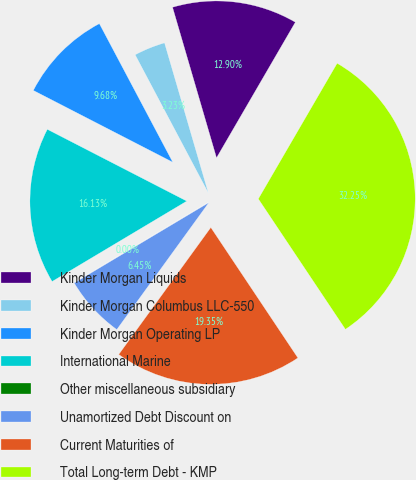<chart> <loc_0><loc_0><loc_500><loc_500><pie_chart><fcel>Kinder Morgan Liquids<fcel>Kinder Morgan Columbus LLC-550<fcel>Kinder Morgan Operating LP<fcel>International Marine<fcel>Other miscellaneous subsidiary<fcel>Unamortized Debt Discount on<fcel>Current Maturities of<fcel>Total Long-term Debt - KMP<nl><fcel>12.9%<fcel>3.23%<fcel>9.68%<fcel>16.13%<fcel>0.0%<fcel>6.45%<fcel>19.35%<fcel>32.25%<nl></chart> 